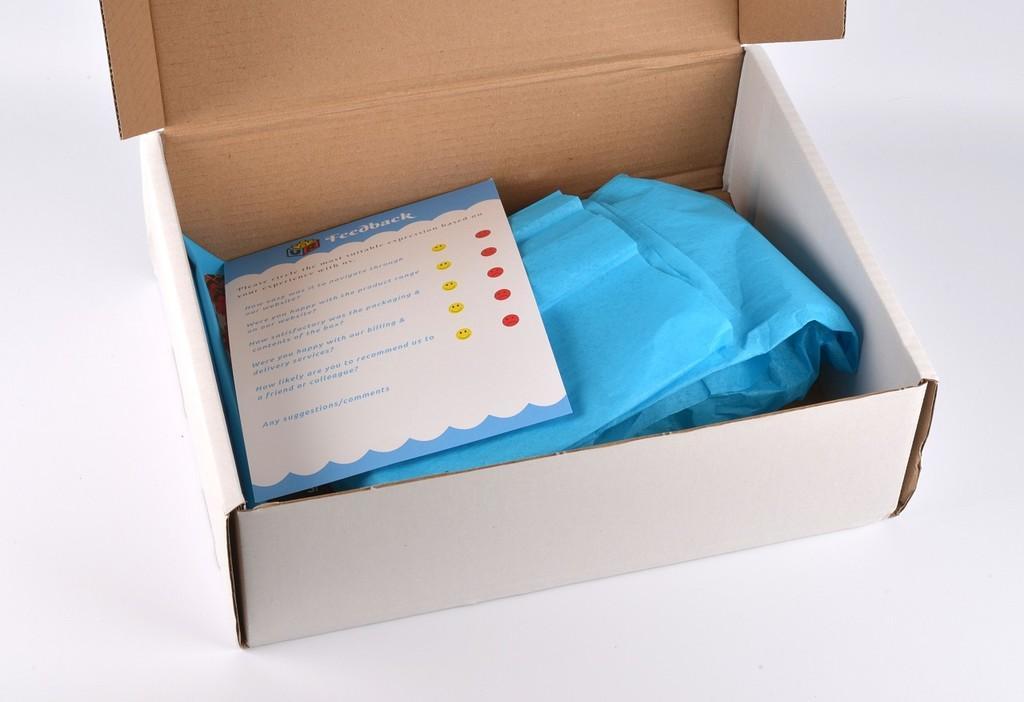Could you give a brief overview of what you see in this image? In this image I can see a cardboard box in white color, inside the cardboard I can see a paper, and a covers in blue color. 